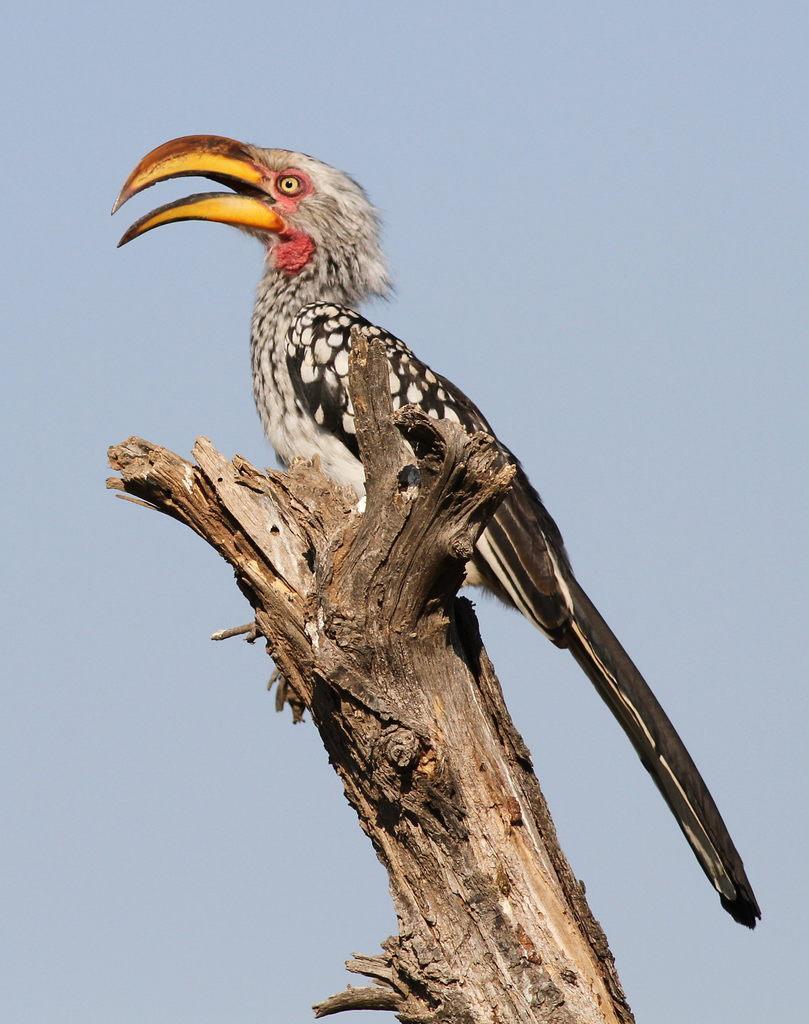Could you give a brief overview of what you see in this image? In this image I can see a bird which is in black and white color. It is on the branch. The sky is in blue and white color. 